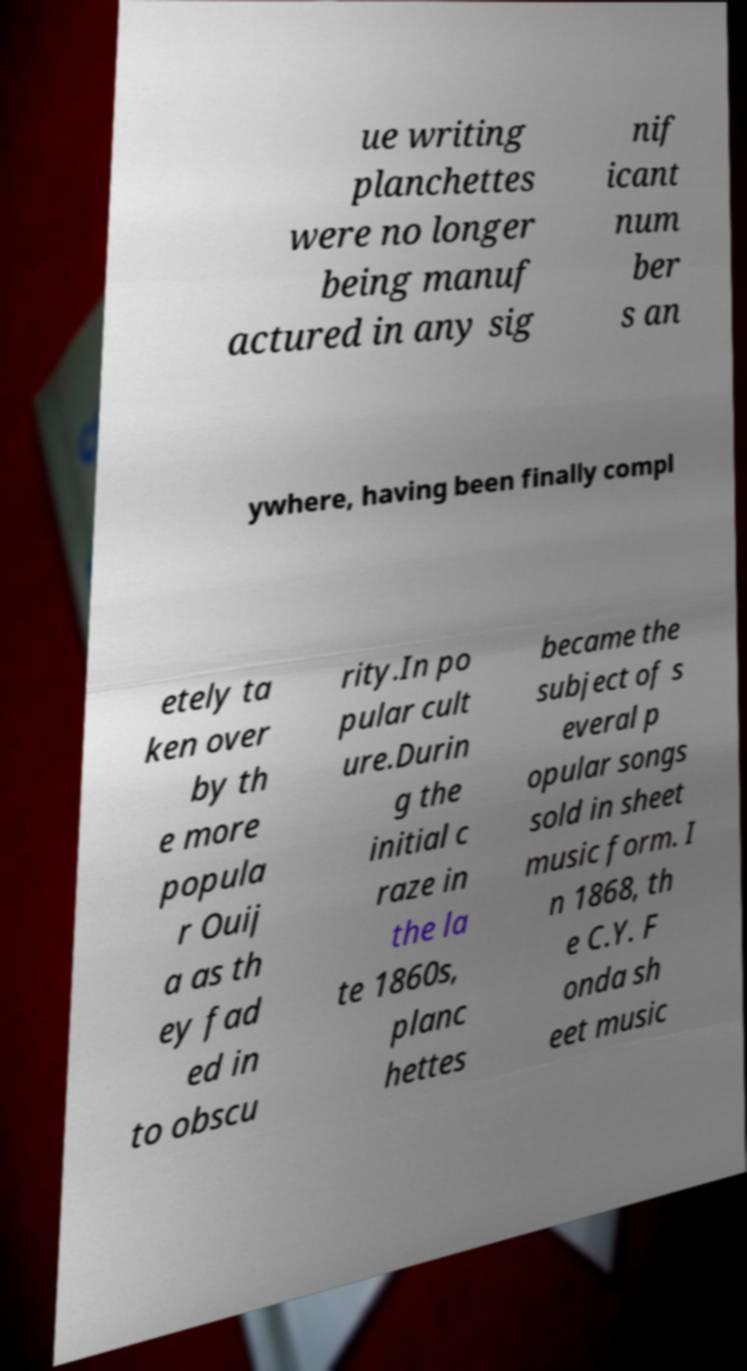I need the written content from this picture converted into text. Can you do that? ue writing planchettes were no longer being manuf actured in any sig nif icant num ber s an ywhere, having been finally compl etely ta ken over by th e more popula r Ouij a as th ey fad ed in to obscu rity.In po pular cult ure.Durin g the initial c raze in the la te 1860s, planc hettes became the subject of s everal p opular songs sold in sheet music form. I n 1868, th e C.Y. F onda sh eet music 